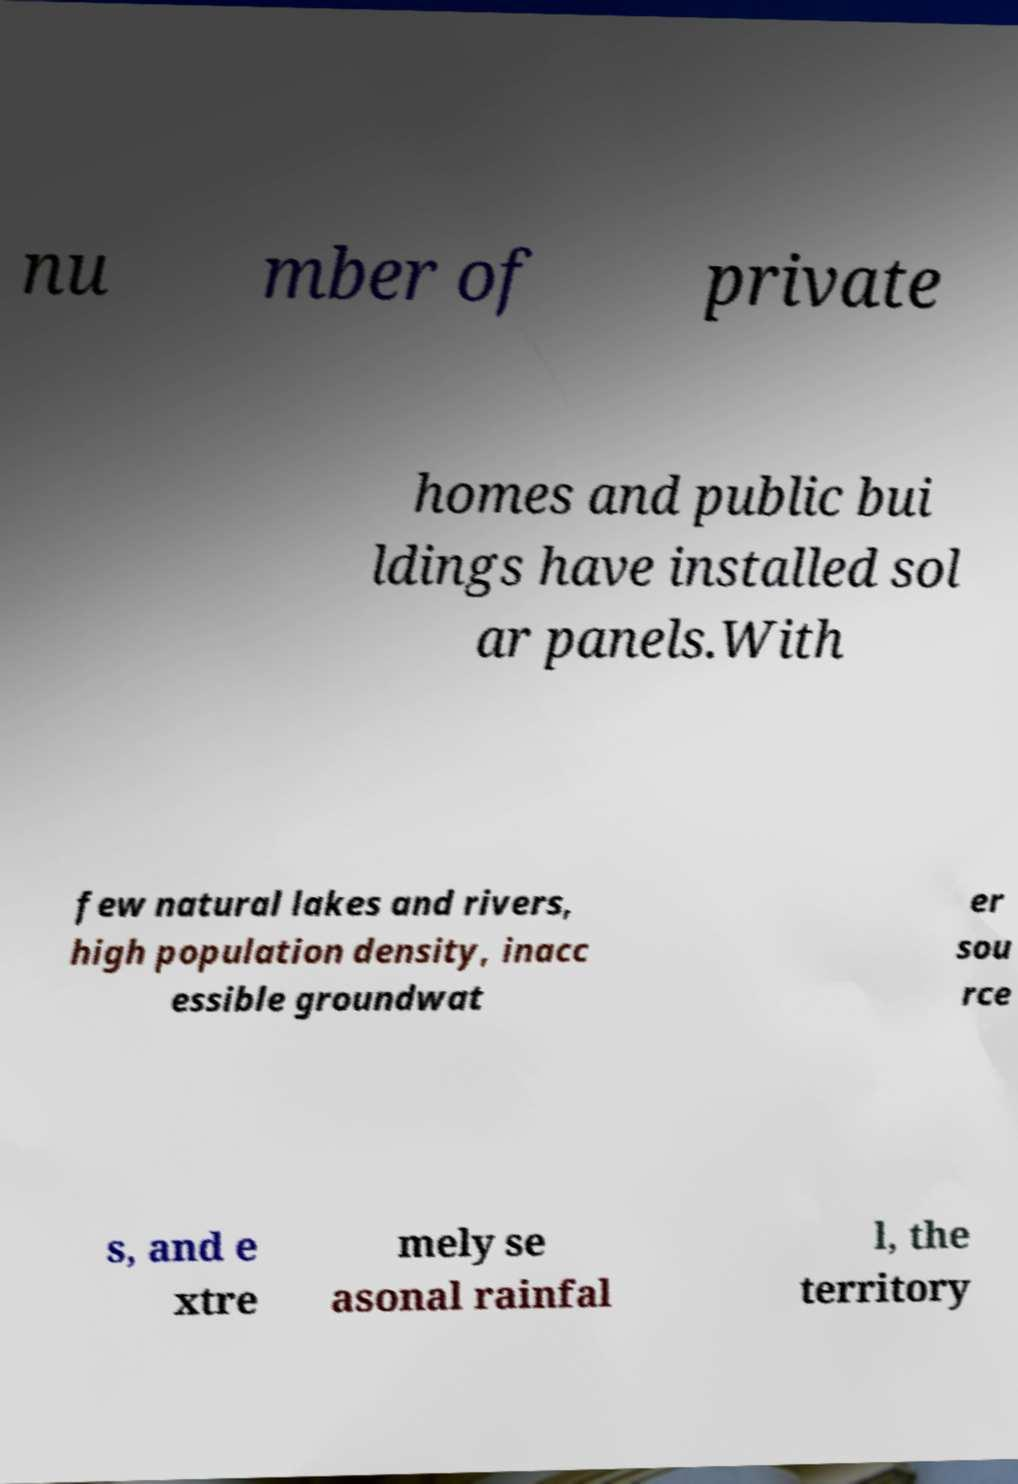Could you assist in decoding the text presented in this image and type it out clearly? nu mber of private homes and public bui ldings have installed sol ar panels.With few natural lakes and rivers, high population density, inacc essible groundwat er sou rce s, and e xtre mely se asonal rainfal l, the territory 